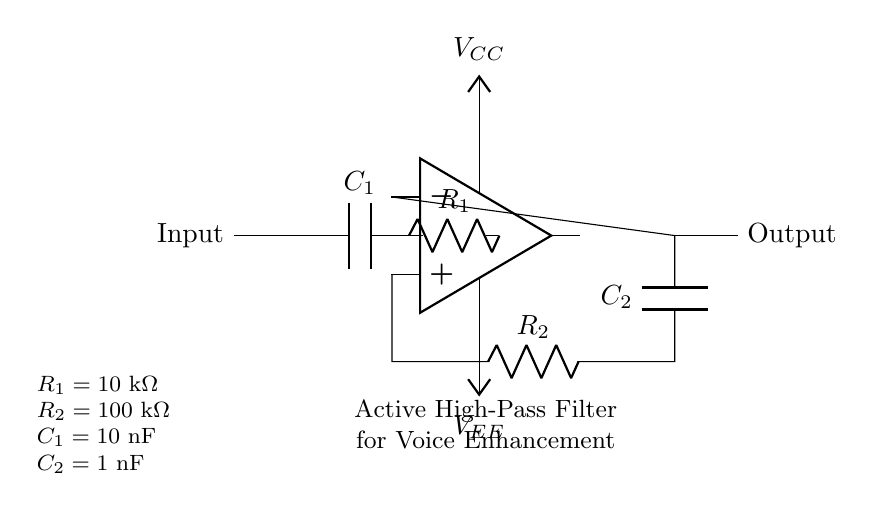What component is used to block low frequencies? The capacitor C1 is the component responsible for blocking low frequencies, as it allows high frequencies to pass through while attenuating the lower ones.
Answer: C1 What is the value of resistance R2? The diagram indicates that the value of resistance R2 is 100 kilohms, as specified in the component values.
Answer: 100 kilohms What is the function of the op-amp in this circuit? The op-amp amplifies the signal, playing a critical role in boosting the output signal of the active filter, ensuring clarity in voice recordings.
Answer: Amplification Which component provides feedback in the circuit? The capacitor C2 and resistor R2 together form the feedback network for the op-amp, essential for setting the performance characteristics of the filter.
Answer: R2 and C2 What type of filter does this circuit represent? The circuit is classified as a high-pass filter due to the arrangement of the components, which predominantly allows higher frequencies to pass while filtering out lower frequencies.
Answer: High-pass filter What are the supply voltages for the op-amp? The supply voltages for the op-amp are labeled as VCC and VEE, representing the positive and negative power supplies respectively.
Answer: VCC and VEE What is the purpose of capacitor C1 in this circuit? Capacitor C1 serves the specific purpose of blocking low-frequency signals, allowing the filter to focus on amplifying higher frequency ranges, such as the human voice.
Answer: Voice enhancement 